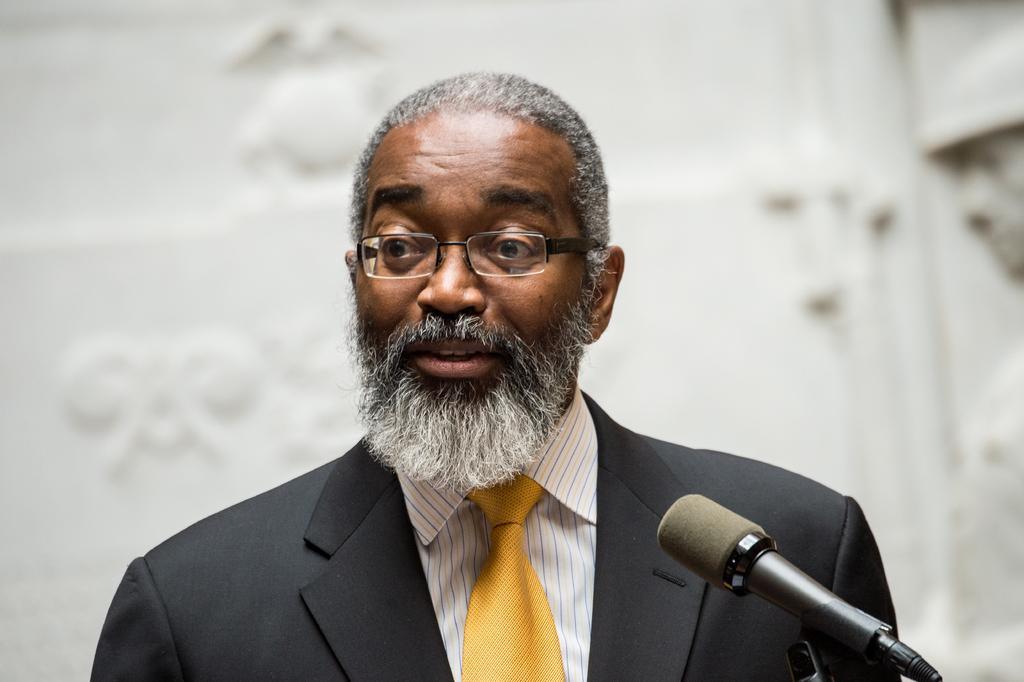How would you summarize this image in a sentence or two? In this image I can see the person wearing the black color blazer, yellow color tie, blue, yellow and white color shirt. I can also see the person with the specs. The person is in-front of the mic. And there is a white background. 